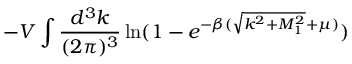<formula> <loc_0><loc_0><loc_500><loc_500>- V \int \frac { d ^ { 3 } k } { ( 2 \pi ) ^ { 3 } } \ln ( 1 - e ^ { - \beta ( \sqrt { k ^ { 2 } + M _ { 1 } ^ { 2 } } + \mu ) } )</formula> 